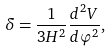Convert formula to latex. <formula><loc_0><loc_0><loc_500><loc_500>\delta = \frac { 1 } { 3 H ^ { 2 } } \frac { d ^ { 2 } V } { d \varphi ^ { 2 } } ,</formula> 